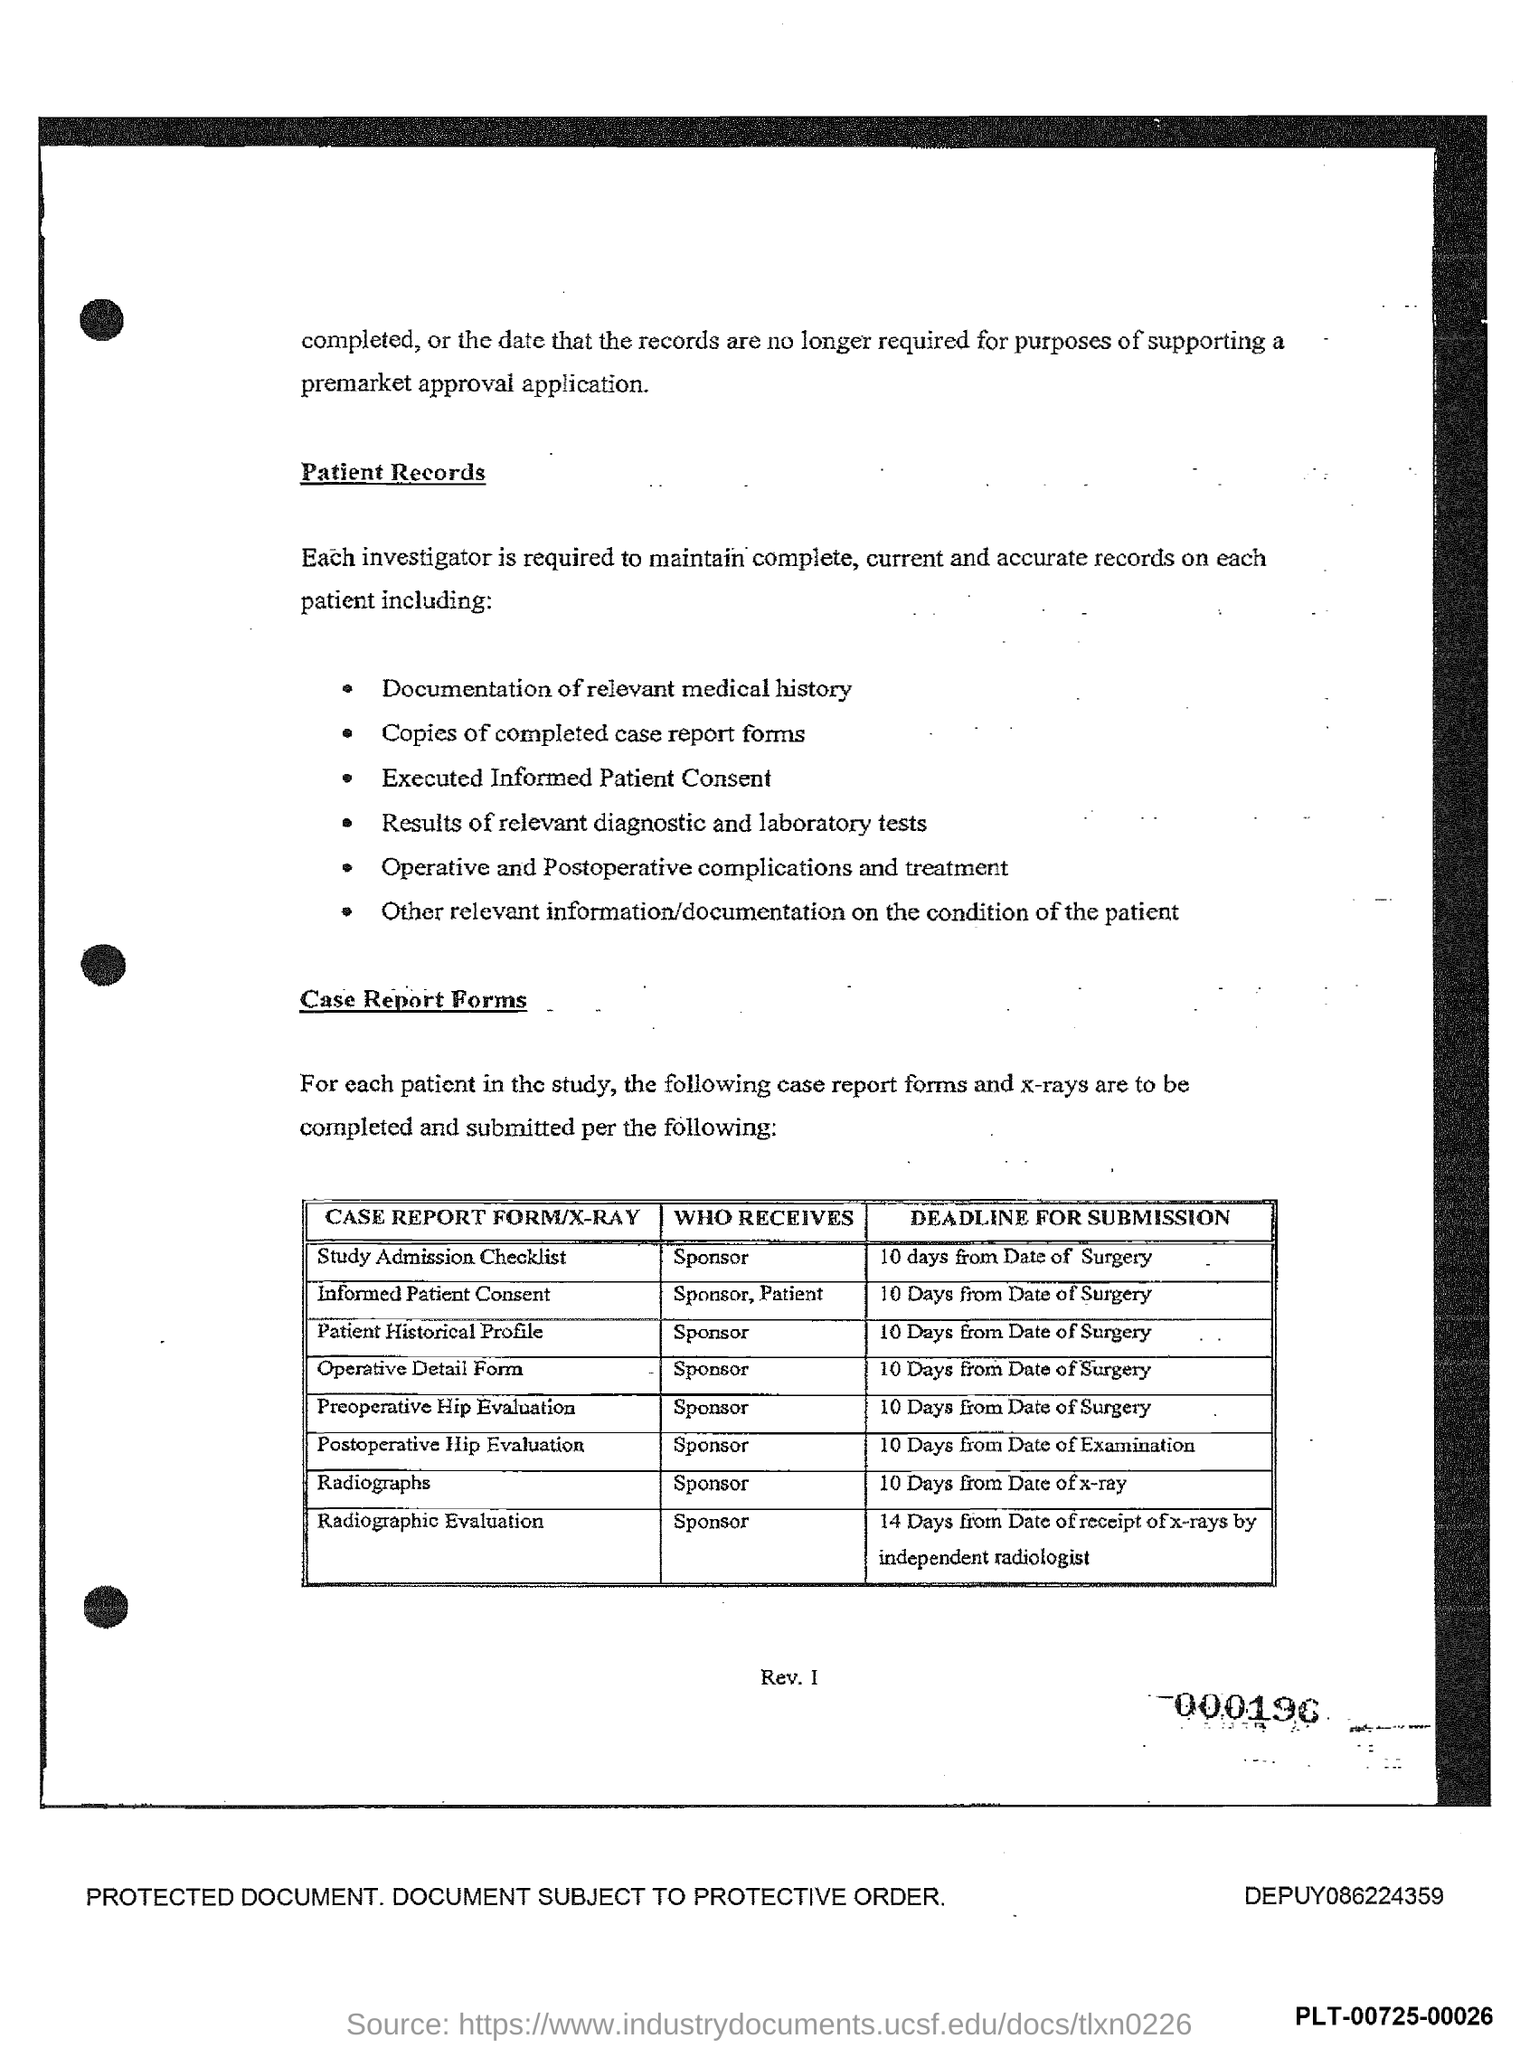What is the deadline for the submission of Informed Patient Consent form?
Ensure brevity in your answer.  10 Days from Date of Surgery. Who receives the Operative detail form as given in the document?
Make the answer very short. Sponsor. What is the deadline for the submission of Radiographs?
Ensure brevity in your answer.  10 Days from Date of x-ray. Who receives the study admission checklist as per the document?
Your answer should be very brief. SPONSOR. What is the deadline for the submission of the Postoperative Hip Evaluation form?
Your answer should be very brief. 10 DAYS FROM THE DATE OF EXAMINATION. 